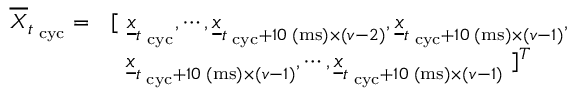Convert formula to latex. <formula><loc_0><loc_0><loc_500><loc_500>\begin{array} { r l } { \overline { \boldsymbol X } _ { t _ { c y c } } = } & { [ \underline { \boldsymbol x } _ { t _ { c y c } } , \cdots , \underline { \boldsymbol x } _ { t _ { c y c } + 1 0 ( m s ) \times ( \boldsymbol v - 2 ) } , \underline { \boldsymbol x } _ { t _ { c y c } + 1 0 ( m s ) \times ( \boldsymbol v - 1 ) } , } \\ & { \underline { \boldsymbol x } _ { t _ { c y c } + 1 0 ( m s ) \times ( \boldsymbol v - 1 ) } , \cdots , \underline { \boldsymbol x } _ { t _ { c y c } + 1 0 ( m s ) \times ( \boldsymbol v - 1 ) } ] ^ { T } } \end{array}</formula> 